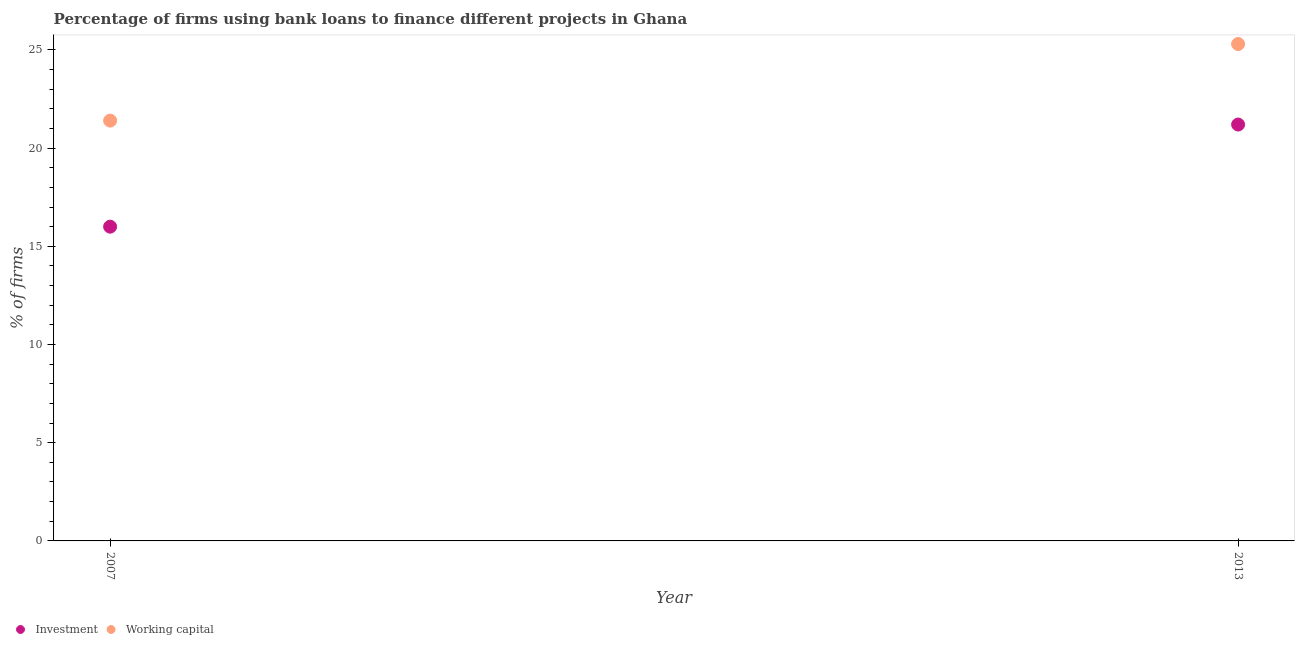Is the number of dotlines equal to the number of legend labels?
Ensure brevity in your answer.  Yes. What is the percentage of firms using banks to finance investment in 2013?
Keep it short and to the point. 21.2. Across all years, what is the maximum percentage of firms using banks to finance investment?
Your answer should be very brief. 21.2. Across all years, what is the minimum percentage of firms using banks to finance working capital?
Your answer should be very brief. 21.4. In which year was the percentage of firms using banks to finance investment maximum?
Provide a short and direct response. 2013. What is the total percentage of firms using banks to finance working capital in the graph?
Your answer should be compact. 46.7. What is the difference between the percentage of firms using banks to finance working capital in 2007 and that in 2013?
Make the answer very short. -3.9. What is the difference between the percentage of firms using banks to finance working capital in 2007 and the percentage of firms using banks to finance investment in 2013?
Offer a terse response. 0.2. What is the average percentage of firms using banks to finance investment per year?
Provide a succinct answer. 18.6. In the year 2013, what is the difference between the percentage of firms using banks to finance investment and percentage of firms using banks to finance working capital?
Your answer should be very brief. -4.1. What is the ratio of the percentage of firms using banks to finance working capital in 2007 to that in 2013?
Offer a terse response. 0.85. Is the percentage of firms using banks to finance investment strictly greater than the percentage of firms using banks to finance working capital over the years?
Make the answer very short. No. Is the percentage of firms using banks to finance working capital strictly less than the percentage of firms using banks to finance investment over the years?
Your response must be concise. No. How many dotlines are there?
Offer a terse response. 2. Are the values on the major ticks of Y-axis written in scientific E-notation?
Make the answer very short. No. Where does the legend appear in the graph?
Your answer should be very brief. Bottom left. How many legend labels are there?
Make the answer very short. 2. What is the title of the graph?
Give a very brief answer. Percentage of firms using bank loans to finance different projects in Ghana. Does "Adolescent fertility rate" appear as one of the legend labels in the graph?
Keep it short and to the point. No. What is the label or title of the X-axis?
Offer a terse response. Year. What is the label or title of the Y-axis?
Your answer should be compact. % of firms. What is the % of firms in Working capital in 2007?
Offer a terse response. 21.4. What is the % of firms of Investment in 2013?
Keep it short and to the point. 21.2. What is the % of firms in Working capital in 2013?
Your answer should be compact. 25.3. Across all years, what is the maximum % of firms in Investment?
Your answer should be compact. 21.2. Across all years, what is the maximum % of firms of Working capital?
Give a very brief answer. 25.3. Across all years, what is the minimum % of firms in Investment?
Your response must be concise. 16. Across all years, what is the minimum % of firms of Working capital?
Your answer should be compact. 21.4. What is the total % of firms of Investment in the graph?
Your answer should be compact. 37.2. What is the total % of firms of Working capital in the graph?
Make the answer very short. 46.7. What is the difference between the % of firms in Investment in 2007 and that in 2013?
Your answer should be very brief. -5.2. What is the difference between the % of firms in Investment in 2007 and the % of firms in Working capital in 2013?
Provide a succinct answer. -9.3. What is the average % of firms in Investment per year?
Keep it short and to the point. 18.6. What is the average % of firms of Working capital per year?
Provide a succinct answer. 23.35. In the year 2007, what is the difference between the % of firms of Investment and % of firms of Working capital?
Provide a short and direct response. -5.4. In the year 2013, what is the difference between the % of firms of Investment and % of firms of Working capital?
Ensure brevity in your answer.  -4.1. What is the ratio of the % of firms of Investment in 2007 to that in 2013?
Ensure brevity in your answer.  0.75. What is the ratio of the % of firms in Working capital in 2007 to that in 2013?
Make the answer very short. 0.85. What is the difference between the highest and the second highest % of firms of Investment?
Provide a short and direct response. 5.2. What is the difference between the highest and the second highest % of firms of Working capital?
Provide a succinct answer. 3.9. What is the difference between the highest and the lowest % of firms in Investment?
Your answer should be very brief. 5.2. 